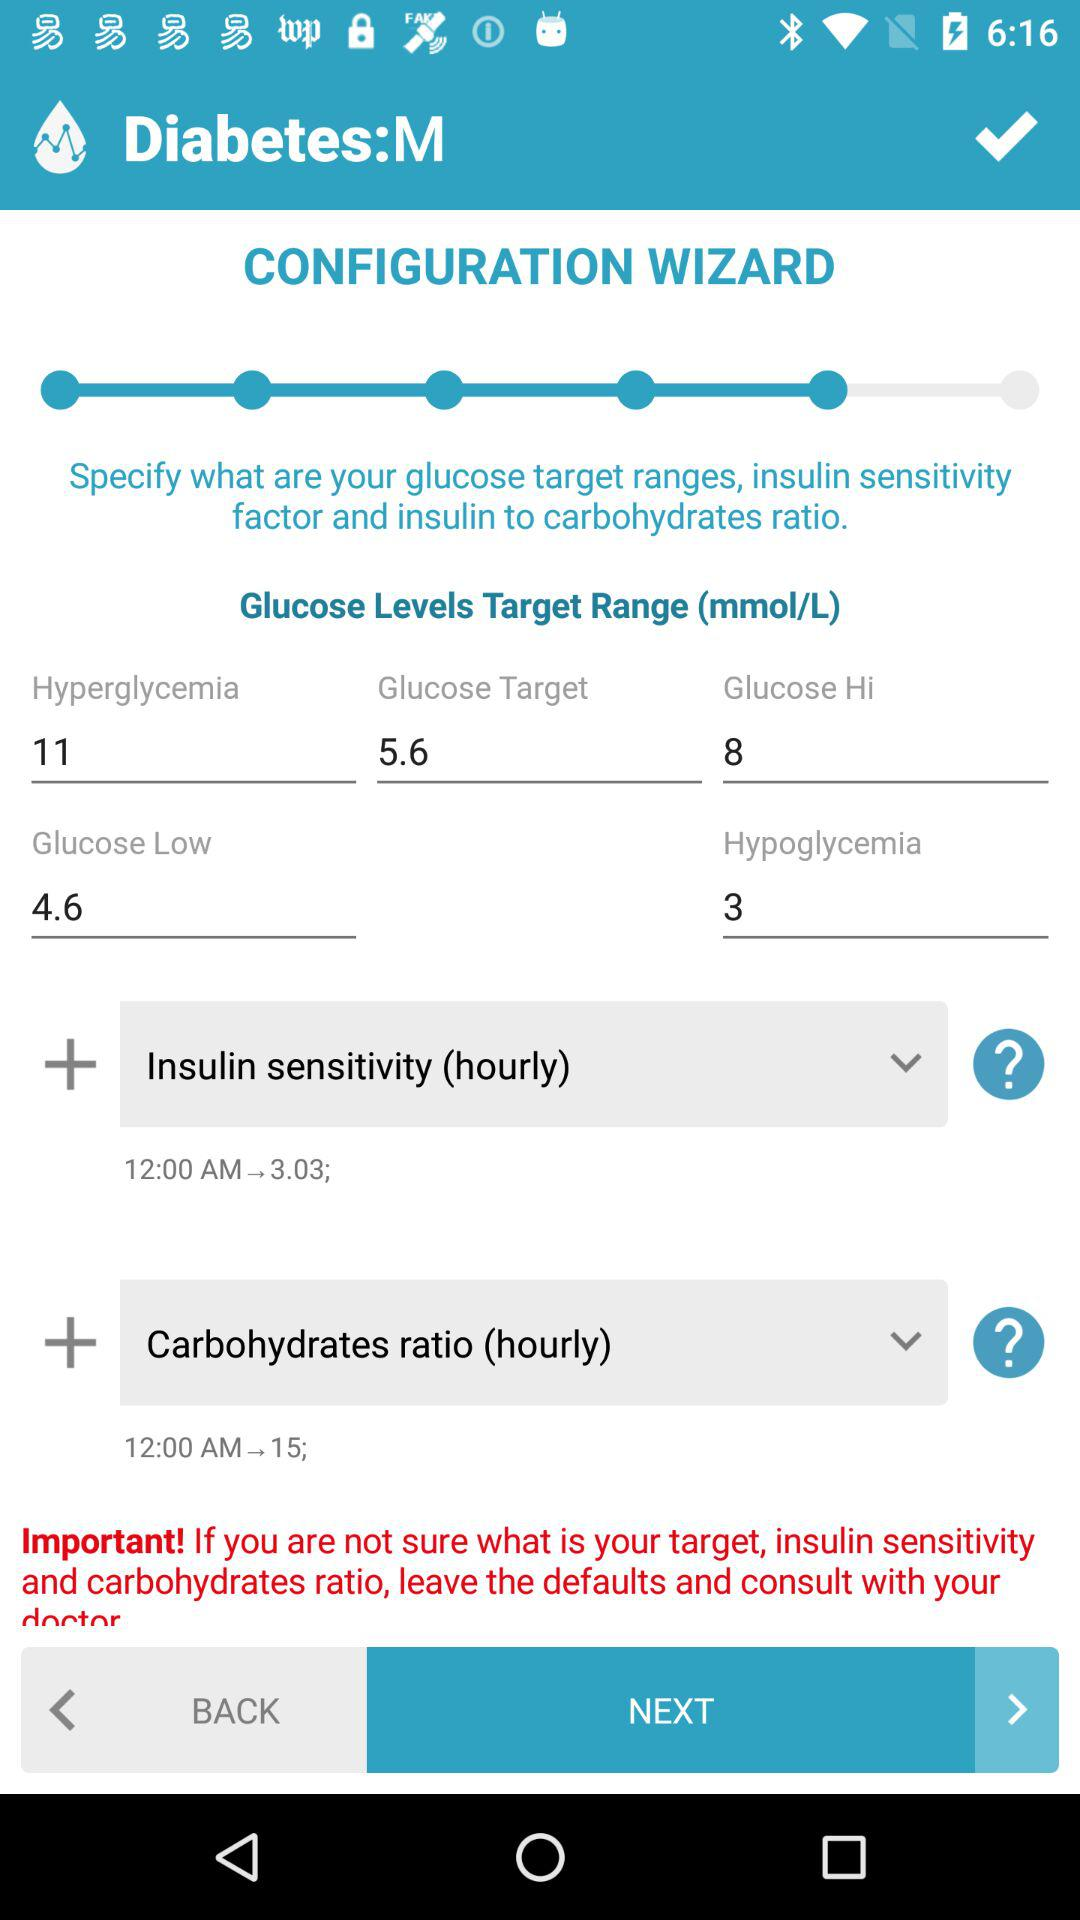What is the glucose target? The glucose target is 5.6 mmol/L. 